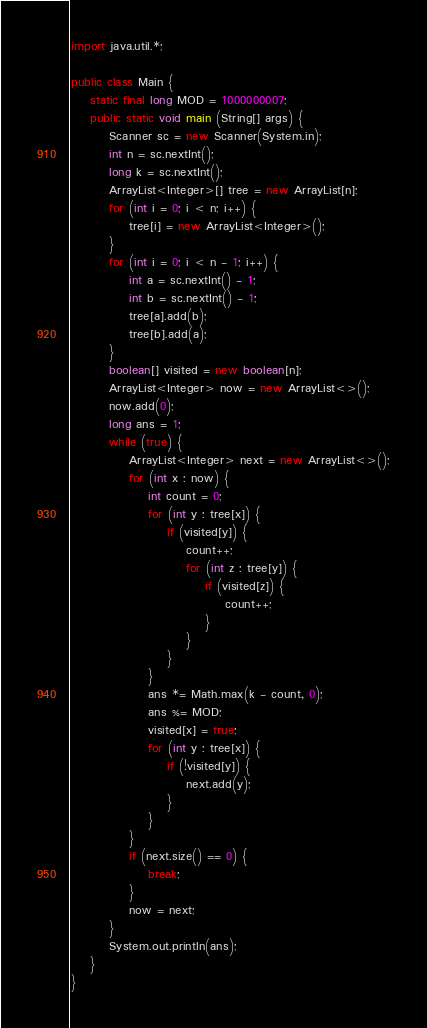Convert code to text. <code><loc_0><loc_0><loc_500><loc_500><_Java_>import java.util.*;

public class Main {
	static final long MOD = 1000000007;
	public static void main (String[] args) {
		Scanner sc = new Scanner(System.in);
		int n = sc.nextInt();
		long k = sc.nextInt();
		ArrayList<Integer>[] tree = new ArrayList[n];
		for (int i = 0; i < n; i++) {
			tree[i] = new ArrayList<Integer>();
		}
		for (int i = 0; i < n - 1; i++) {
			int a = sc.nextInt() - 1;
			int b = sc.nextInt() - 1;
			tree[a].add(b);
			tree[b].add(a);
		}
		boolean[] visited = new boolean[n];
		ArrayList<Integer> now = new ArrayList<>();
		now.add(0);
		long ans = 1;
		while (true) {
			ArrayList<Integer> next = new ArrayList<>();
			for (int x : now) {
				int count = 0;
				for (int y : tree[x]) {
					if (visited[y]) {
						count++;
						for (int z : tree[y]) {
							if (visited[z]) {
								count++;
							}
						}
					}
				}
				ans *= Math.max(k - count, 0);
				ans %= MOD;
				visited[x] = true;
				for (int y : tree[x]) {
					if (!visited[y]) {
						next.add(y);
					}
				}
			}
			if (next.size() == 0) {
				break;
			}
			now = next;
		}
		System.out.println(ans);
	}
}
</code> 